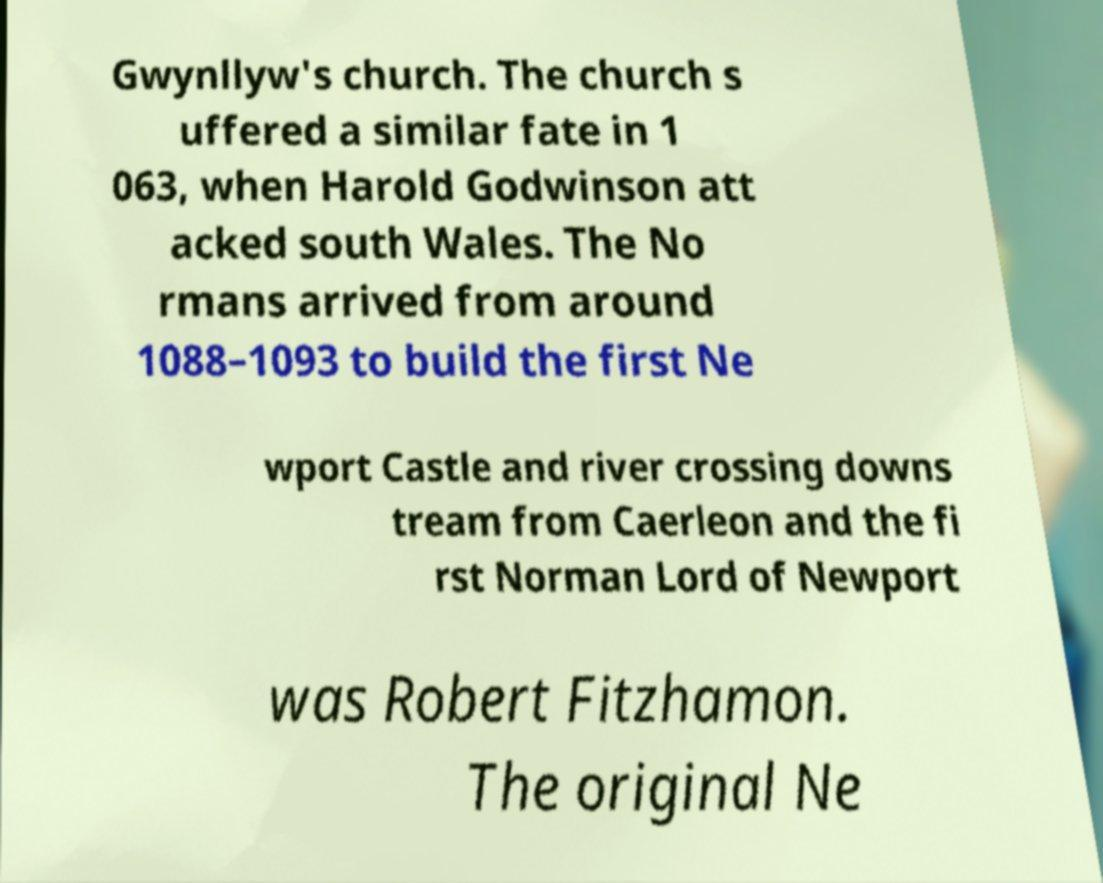Can you read and provide the text displayed in the image?This photo seems to have some interesting text. Can you extract and type it out for me? Gwynllyw's church. The church s uffered a similar fate in 1 063, when Harold Godwinson att acked south Wales. The No rmans arrived from around 1088–1093 to build the first Ne wport Castle and river crossing downs tream from Caerleon and the fi rst Norman Lord of Newport was Robert Fitzhamon. The original Ne 